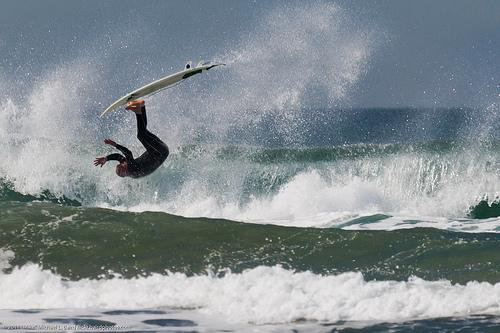In a few sentences, characterize the main elements and actions visible in the image. A man in a black wetsuit is captured in mid-fall while surfing on a large, crashing wave. He is upside down in the air, momentarily separated from his white surfboard with black accents and two fins. Summarize the scene depicted in the image concisely. A surfer in a black wetsuit tumbles in the air on a white and black surfboard amidst large ocean waves. Concisely explain what is transpiring in the image with emphasis on the principal subject. A surfer, wearing a wetsuit, plunges in the air while attempting to ride vigorous waves on his white and black surfboard with two fins. Outline the primary event occurring in the image. The image shows a man in a black wetsuit caught mid-fall, upside down in the air, moments after losing grip on his white and black surfboard with two fins amidst raging ocean waves. Explain the focal point of the image and what is happening. The image highlights a man in a wetsuit, caught mid-fall and upside down in the air, as he attempts to surf on his white and black surfboard amongst large, turbulent waves. Narrate the main event taking place within the image. The image captures the moment when a surfer, clad in a black wetsuit, loses his footing on his white and black surfboard and consequently tumbles upside down in the air amidst raging ocean waves. Provide a brief description of the situation portrayed in the image. In the midst of riding a large wave, a man wearing a wetsuit loses balance and falls upside down off his black and white surfboard. Describe the image focusing on the primary subject and their actions. A surfer dressed in a wetsuit is seen falling in the air, upside down, after losing balance on his white surfboard with black elements, as he rides the waves of a rough ocean. Elaborate on the key aspects of the image. A man donning a wetsuit is seen upside down in the air, falling from his white and black surfboard while riding the crashing waves of a seemingly dirty ocean. Mention the primary figure and their activities in the photograph. An individual in a wetsuit is falling upside down in the air while surfing on a white surfboard with black detailing and two fins in the ocean with large, crashing waves. 